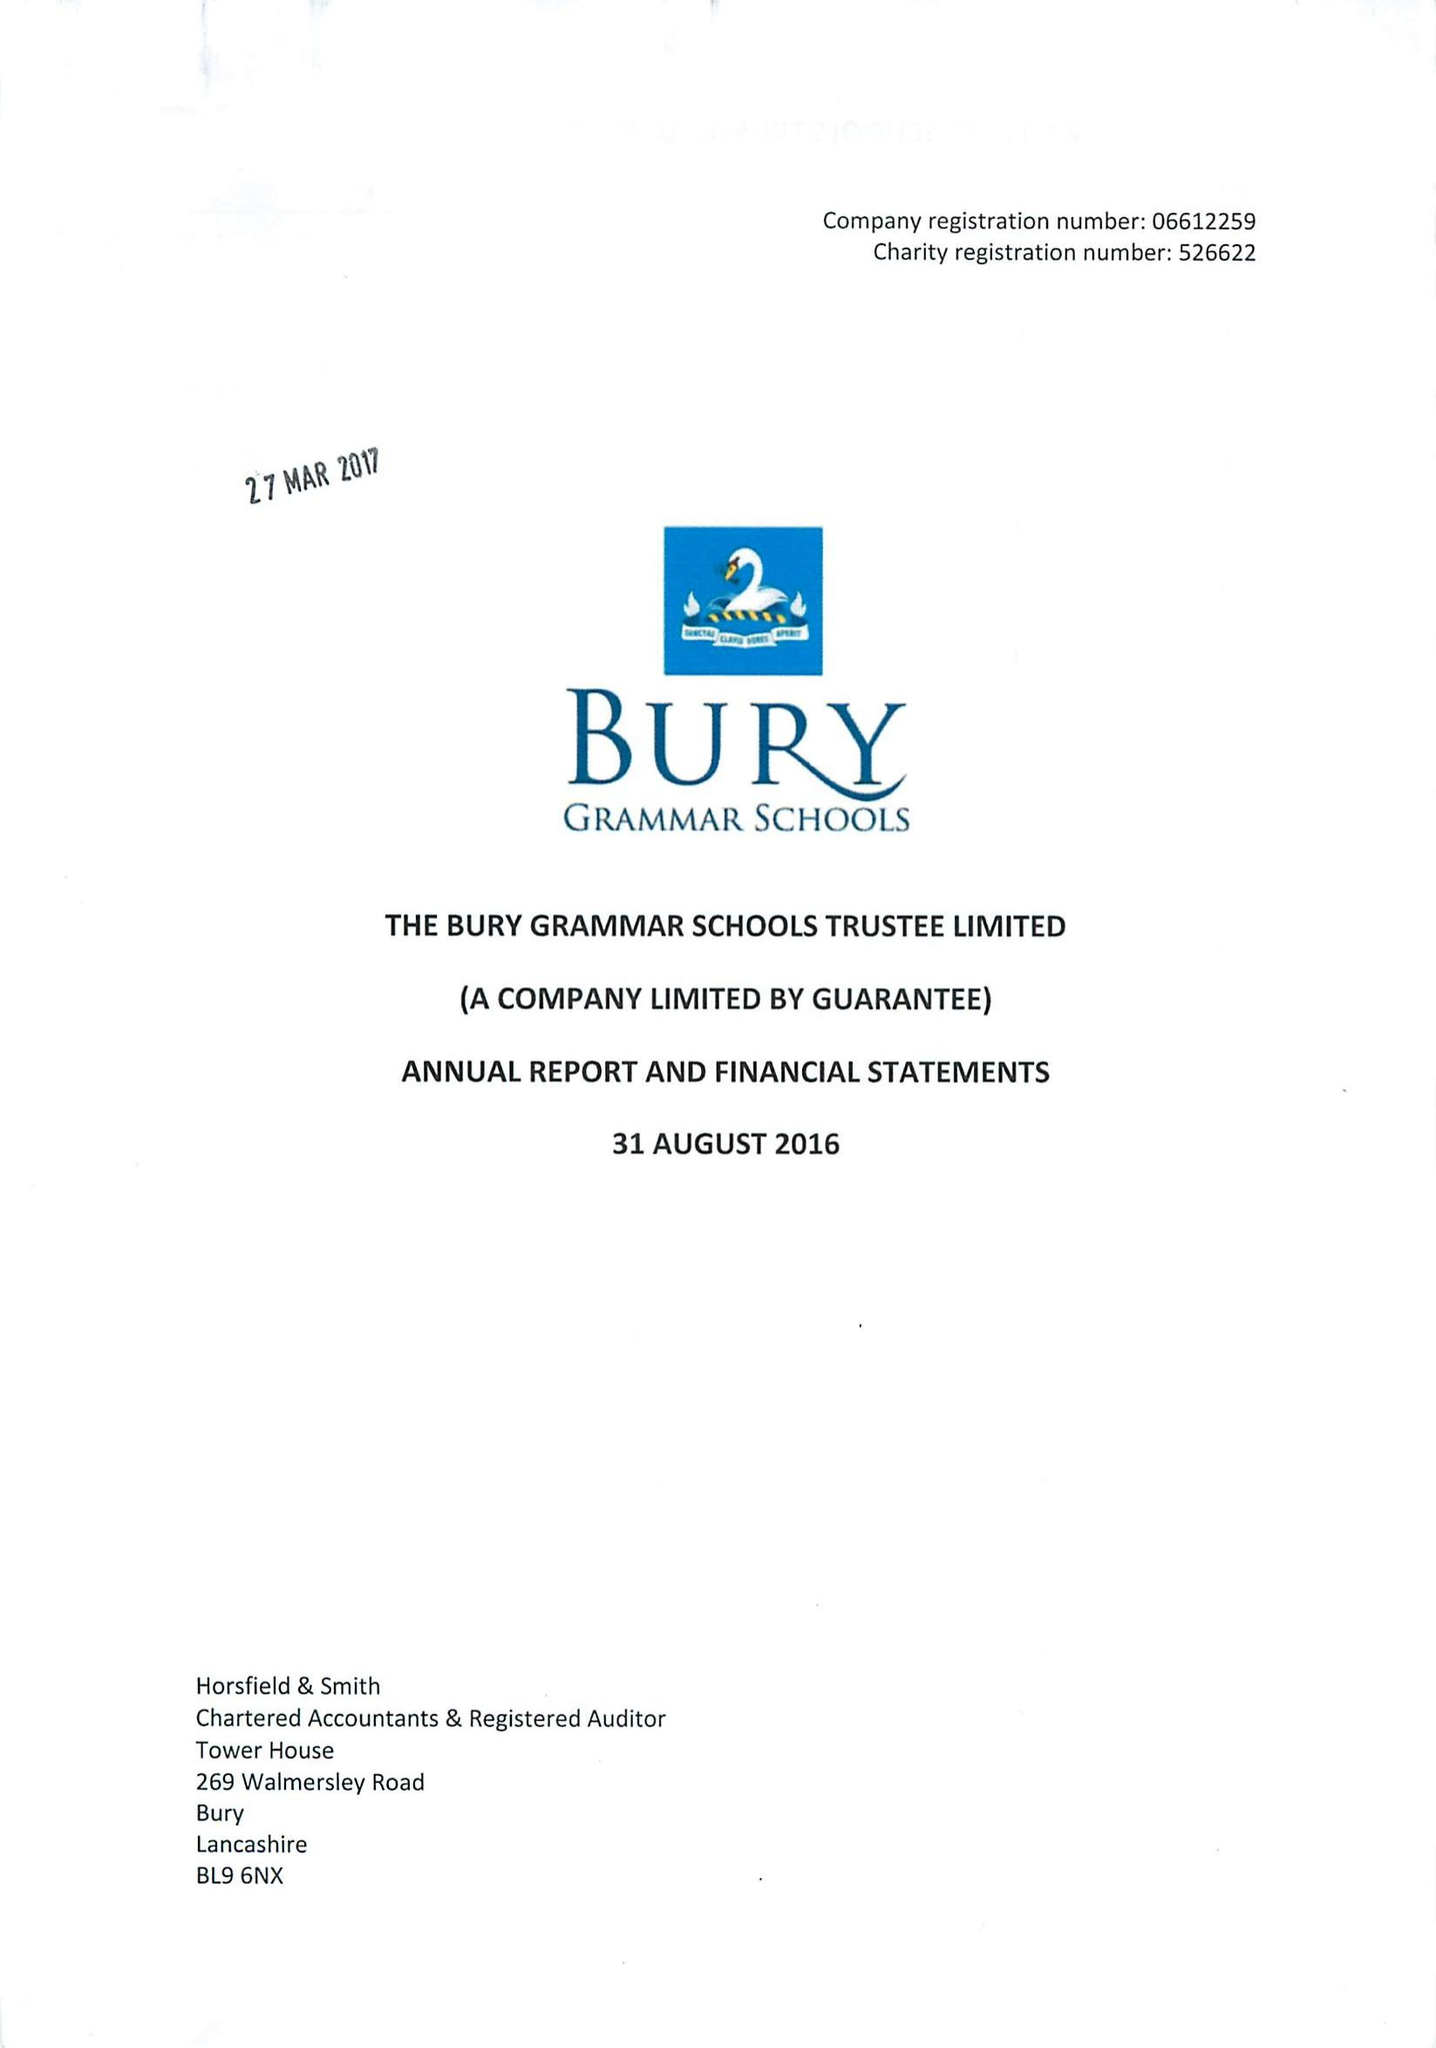What is the value for the charity_name?
Answer the question using a single word or phrase. Bury Grammar Schools Trustee Ltd. 